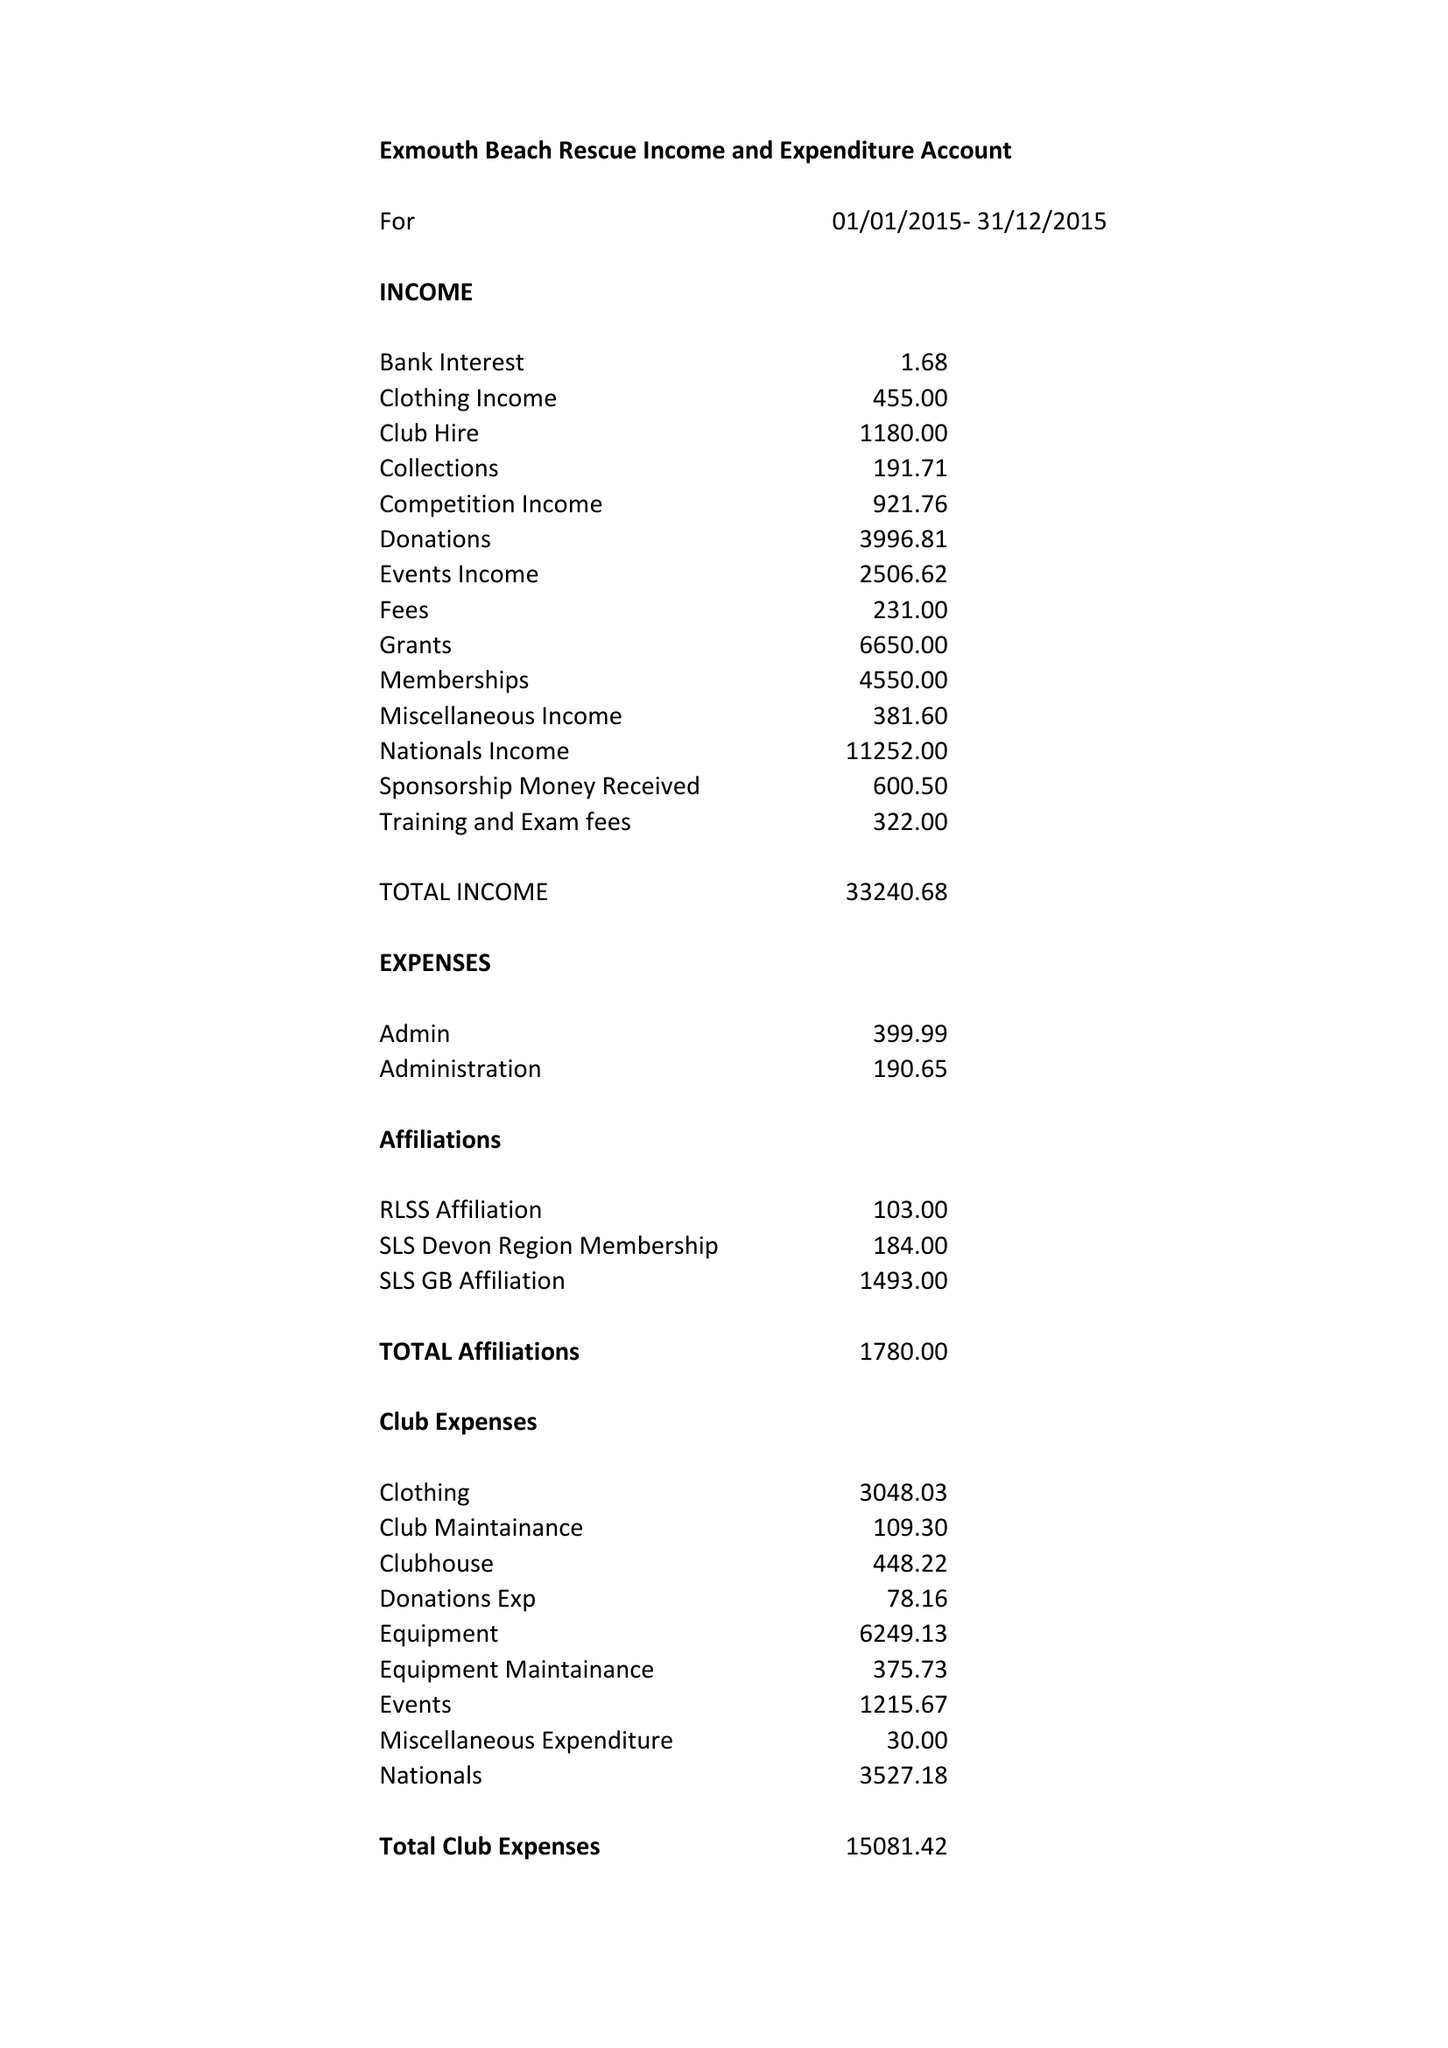What is the value for the spending_annually_in_british_pounds?
Answer the question using a single word or phrase. 22821.00 